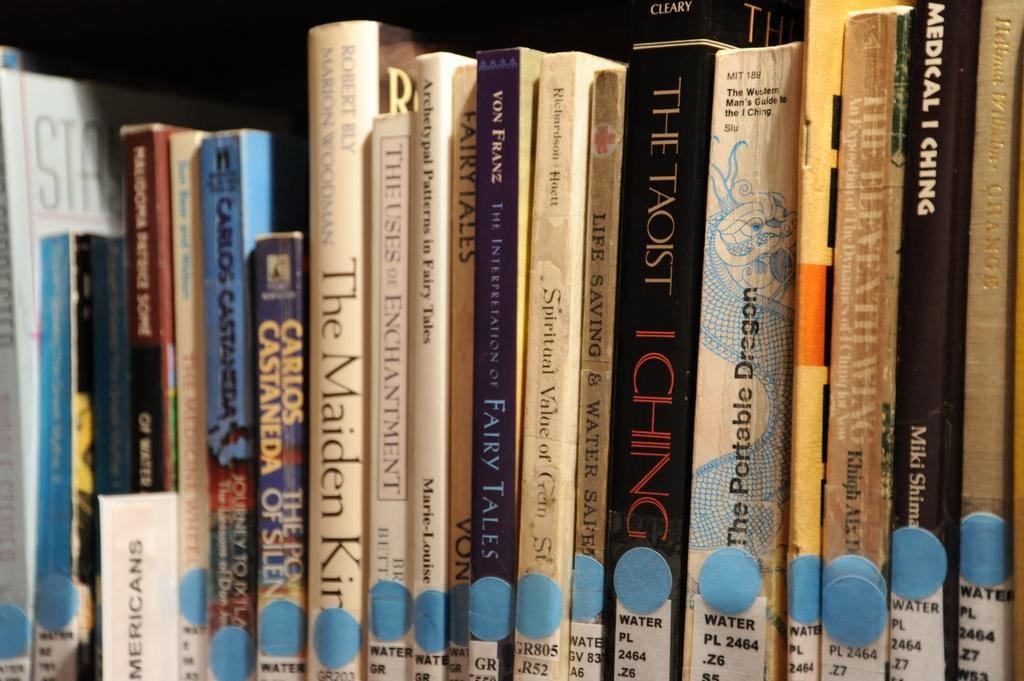What is the main subject of the image? The main subject of the image is a group of books. Can you describe the background of the image? The background of the image is dark. What type of pizzas are being served in the image? There are no pizzas present in the image; it features a group of books. What type of learning can be observed in the image? The image does not show any learning taking place; it only shows a group of books. 